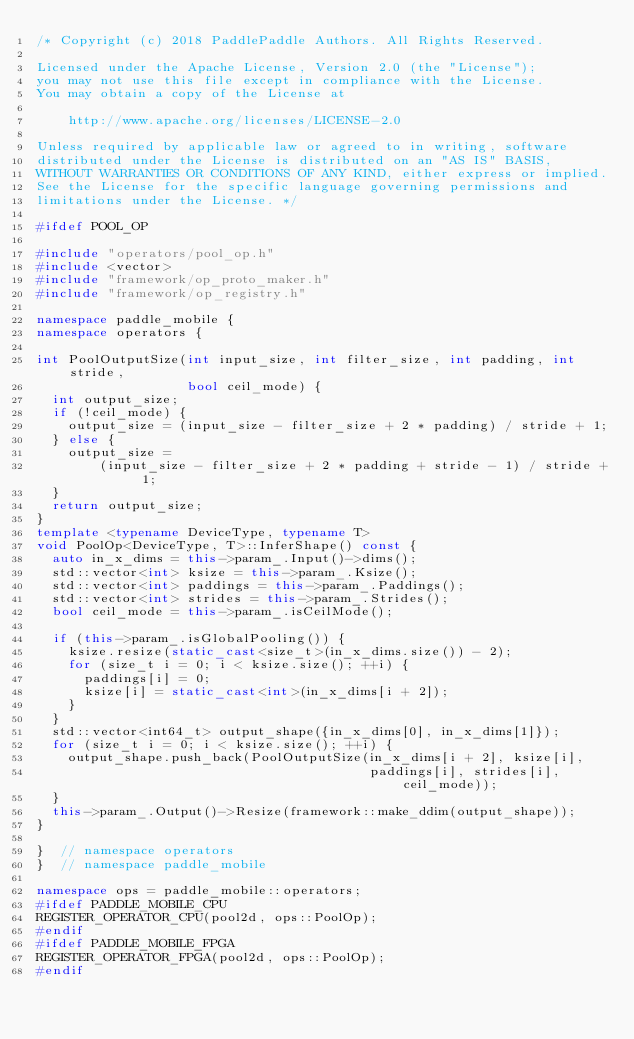Convert code to text. <code><loc_0><loc_0><loc_500><loc_500><_C++_>/* Copyright (c) 2018 PaddlePaddle Authors. All Rights Reserved.

Licensed under the Apache License, Version 2.0 (the "License");
you may not use this file except in compliance with the License.
You may obtain a copy of the License at

    http://www.apache.org/licenses/LICENSE-2.0

Unless required by applicable law or agreed to in writing, software
distributed under the License is distributed on an "AS IS" BASIS,
WITHOUT WARRANTIES OR CONDITIONS OF ANY KIND, either express or implied.
See the License for the specific language governing permissions and
limitations under the License. */

#ifdef POOL_OP

#include "operators/pool_op.h"
#include <vector>
#include "framework/op_proto_maker.h"
#include "framework/op_registry.h"

namespace paddle_mobile {
namespace operators {

int PoolOutputSize(int input_size, int filter_size, int padding, int stride,
                   bool ceil_mode) {
  int output_size;
  if (!ceil_mode) {
    output_size = (input_size - filter_size + 2 * padding) / stride + 1;
  } else {
    output_size =
        (input_size - filter_size + 2 * padding + stride - 1) / stride + 1;
  }
  return output_size;
}
template <typename DeviceType, typename T>
void PoolOp<DeviceType, T>::InferShape() const {
  auto in_x_dims = this->param_.Input()->dims();
  std::vector<int> ksize = this->param_.Ksize();
  std::vector<int> paddings = this->param_.Paddings();
  std::vector<int> strides = this->param_.Strides();
  bool ceil_mode = this->param_.isCeilMode();

  if (this->param_.isGlobalPooling()) {
    ksize.resize(static_cast<size_t>(in_x_dims.size()) - 2);
    for (size_t i = 0; i < ksize.size(); ++i) {
      paddings[i] = 0;
      ksize[i] = static_cast<int>(in_x_dims[i + 2]);
    }
  }
  std::vector<int64_t> output_shape({in_x_dims[0], in_x_dims[1]});
  for (size_t i = 0; i < ksize.size(); ++i) {
    output_shape.push_back(PoolOutputSize(in_x_dims[i + 2], ksize[i],
                                          paddings[i], strides[i], ceil_mode));
  }
  this->param_.Output()->Resize(framework::make_ddim(output_shape));
}

}  // namespace operators
}  // namespace paddle_mobile

namespace ops = paddle_mobile::operators;
#ifdef PADDLE_MOBILE_CPU
REGISTER_OPERATOR_CPU(pool2d, ops::PoolOp);
#endif
#ifdef PADDLE_MOBILE_FPGA
REGISTER_OPERATOR_FPGA(pool2d, ops::PoolOp);
#endif</code> 